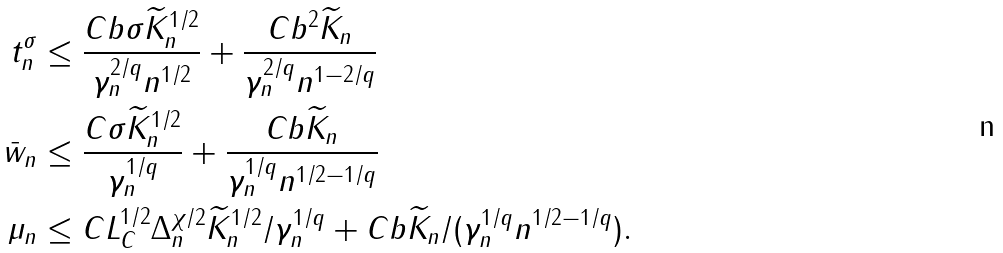<formula> <loc_0><loc_0><loc_500><loc_500>t _ { n } ^ { \sigma } & \leq \frac { C b \sigma \widetilde { K } _ { n } ^ { 1 / 2 } } { \gamma _ { n } ^ { 2 / q } n ^ { 1 / 2 } } + \frac { C b ^ { 2 } \widetilde { K } _ { n } } { \gamma _ { n } ^ { 2 / q } n ^ { 1 - 2 / q } } \\ \bar { w } _ { n } & \leq \frac { C \sigma \widetilde { K } _ { n } ^ { 1 / 2 } } { \gamma _ { n } ^ { 1 / q } } + \frac { C b \widetilde { K } _ { n } } { \gamma _ { n } ^ { 1 / q } n ^ { 1 / 2 - 1 / q } } \\ \mu _ { n } & \leq C L _ { C } ^ { 1 / 2 } \Delta _ { n } ^ { \chi / 2 } \widetilde { K } _ { n } ^ { 1 / 2 } / \gamma _ { n } ^ { 1 / q } + C b \widetilde { K } _ { n } / ( \gamma _ { n } ^ { 1 / q } n ^ { 1 / 2 - 1 / q } ) .</formula> 